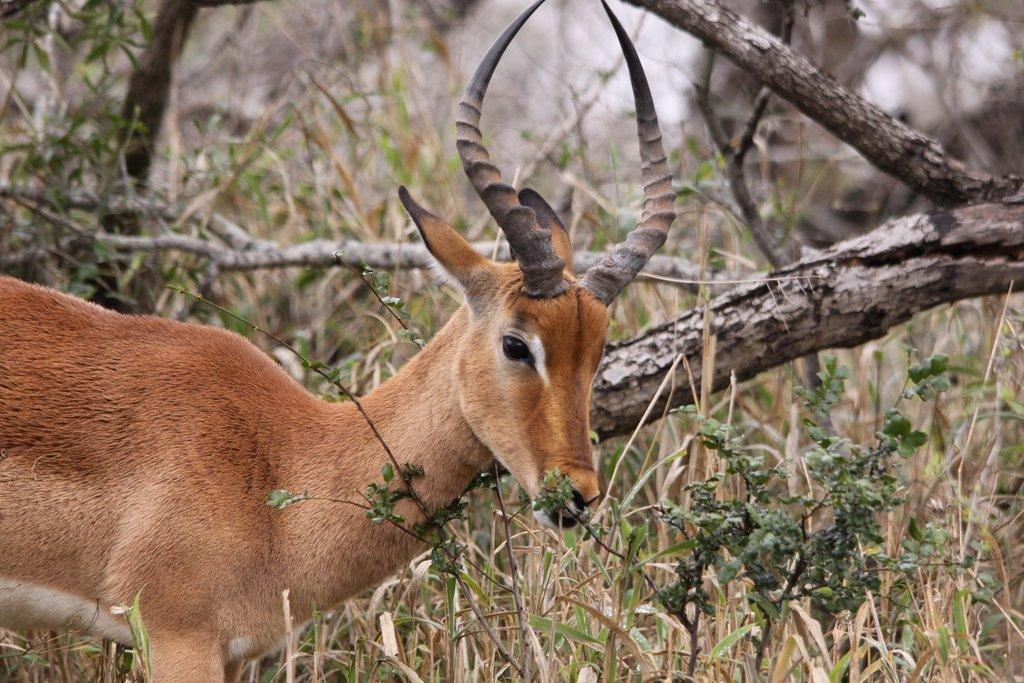What type of animal is in the image? There is an animal in the image, but the specific type cannot be determined from the provided facts. What can be seen in the background of the image? In the background of the image, there are branches of trees, plants, and grass. What year is the animal laughing in the image? The image does not depict the animal laughing, nor does it provide any information about the year. 